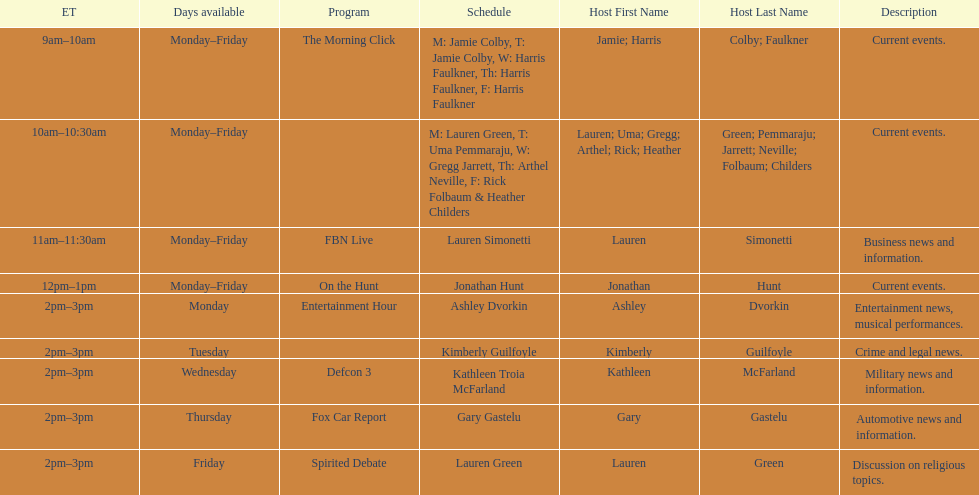How many days is fbn live available each week? 5. 